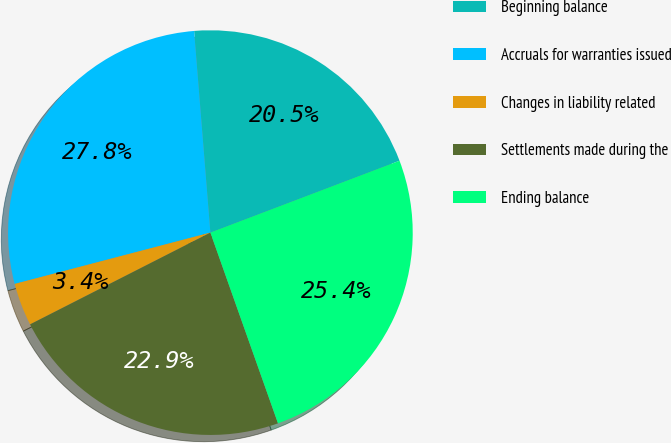Convert chart to OTSL. <chart><loc_0><loc_0><loc_500><loc_500><pie_chart><fcel>Beginning balance<fcel>Accruals for warranties issued<fcel>Changes in liability related<fcel>Settlements made during the<fcel>Ending balance<nl><fcel>20.5%<fcel>27.8%<fcel>3.41%<fcel>22.93%<fcel>25.36%<nl></chart> 